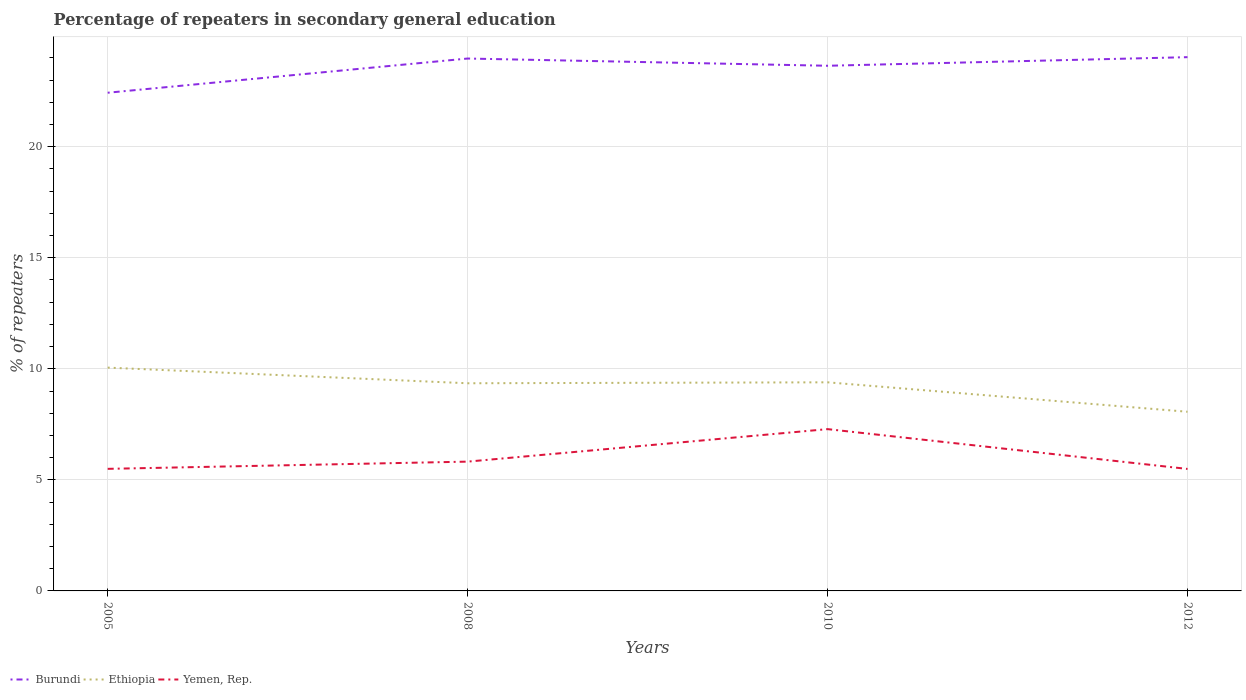How many different coloured lines are there?
Provide a succinct answer. 3. Does the line corresponding to Ethiopia intersect with the line corresponding to Yemen, Rep.?
Offer a very short reply. No. Across all years, what is the maximum percentage of repeaters in secondary general education in Ethiopia?
Offer a very short reply. 8.07. What is the total percentage of repeaters in secondary general education in Yemen, Rep. in the graph?
Ensure brevity in your answer.  0. What is the difference between the highest and the second highest percentage of repeaters in secondary general education in Ethiopia?
Make the answer very short. 1.99. Is the percentage of repeaters in secondary general education in Burundi strictly greater than the percentage of repeaters in secondary general education in Yemen, Rep. over the years?
Offer a very short reply. No. How many years are there in the graph?
Offer a terse response. 4. What is the difference between two consecutive major ticks on the Y-axis?
Ensure brevity in your answer.  5. Are the values on the major ticks of Y-axis written in scientific E-notation?
Give a very brief answer. No. Does the graph contain any zero values?
Your answer should be compact. No. Where does the legend appear in the graph?
Your answer should be very brief. Bottom left. How are the legend labels stacked?
Provide a short and direct response. Horizontal. What is the title of the graph?
Your response must be concise. Percentage of repeaters in secondary general education. Does "Djibouti" appear as one of the legend labels in the graph?
Your response must be concise. No. What is the label or title of the Y-axis?
Make the answer very short. % of repeaters. What is the % of repeaters of Burundi in 2005?
Make the answer very short. 22.43. What is the % of repeaters of Ethiopia in 2005?
Provide a succinct answer. 10.05. What is the % of repeaters in Yemen, Rep. in 2005?
Offer a terse response. 5.5. What is the % of repeaters in Burundi in 2008?
Your answer should be very brief. 23.97. What is the % of repeaters of Ethiopia in 2008?
Offer a terse response. 9.35. What is the % of repeaters of Yemen, Rep. in 2008?
Provide a short and direct response. 5.82. What is the % of repeaters of Burundi in 2010?
Provide a succinct answer. 23.64. What is the % of repeaters of Ethiopia in 2010?
Provide a short and direct response. 9.39. What is the % of repeaters of Yemen, Rep. in 2010?
Keep it short and to the point. 7.28. What is the % of repeaters of Burundi in 2012?
Your answer should be very brief. 24.03. What is the % of repeaters of Ethiopia in 2012?
Your answer should be compact. 8.07. What is the % of repeaters in Yemen, Rep. in 2012?
Your answer should be compact. 5.49. Across all years, what is the maximum % of repeaters of Burundi?
Keep it short and to the point. 24.03. Across all years, what is the maximum % of repeaters of Ethiopia?
Your response must be concise. 10.05. Across all years, what is the maximum % of repeaters of Yemen, Rep.?
Your answer should be very brief. 7.28. Across all years, what is the minimum % of repeaters of Burundi?
Ensure brevity in your answer.  22.43. Across all years, what is the minimum % of repeaters in Ethiopia?
Provide a short and direct response. 8.07. Across all years, what is the minimum % of repeaters in Yemen, Rep.?
Provide a short and direct response. 5.49. What is the total % of repeaters in Burundi in the graph?
Offer a terse response. 94.08. What is the total % of repeaters in Ethiopia in the graph?
Ensure brevity in your answer.  36.86. What is the total % of repeaters in Yemen, Rep. in the graph?
Make the answer very short. 24.09. What is the difference between the % of repeaters of Burundi in 2005 and that in 2008?
Make the answer very short. -1.54. What is the difference between the % of repeaters in Ethiopia in 2005 and that in 2008?
Keep it short and to the point. 0.7. What is the difference between the % of repeaters in Yemen, Rep. in 2005 and that in 2008?
Your response must be concise. -0.33. What is the difference between the % of repeaters in Burundi in 2005 and that in 2010?
Your answer should be compact. -1.21. What is the difference between the % of repeaters of Ethiopia in 2005 and that in 2010?
Give a very brief answer. 0.66. What is the difference between the % of repeaters in Yemen, Rep. in 2005 and that in 2010?
Your answer should be very brief. -1.79. What is the difference between the % of repeaters in Burundi in 2005 and that in 2012?
Offer a terse response. -1.6. What is the difference between the % of repeaters of Ethiopia in 2005 and that in 2012?
Offer a terse response. 1.99. What is the difference between the % of repeaters of Yemen, Rep. in 2005 and that in 2012?
Your answer should be compact. 0. What is the difference between the % of repeaters in Burundi in 2008 and that in 2010?
Provide a short and direct response. 0.33. What is the difference between the % of repeaters of Ethiopia in 2008 and that in 2010?
Make the answer very short. -0.04. What is the difference between the % of repeaters in Yemen, Rep. in 2008 and that in 2010?
Your answer should be very brief. -1.46. What is the difference between the % of repeaters of Burundi in 2008 and that in 2012?
Ensure brevity in your answer.  -0.06. What is the difference between the % of repeaters in Ethiopia in 2008 and that in 2012?
Make the answer very short. 1.28. What is the difference between the % of repeaters in Yemen, Rep. in 2008 and that in 2012?
Make the answer very short. 0.33. What is the difference between the % of repeaters in Burundi in 2010 and that in 2012?
Keep it short and to the point. -0.39. What is the difference between the % of repeaters of Ethiopia in 2010 and that in 2012?
Your answer should be very brief. 1.33. What is the difference between the % of repeaters in Yemen, Rep. in 2010 and that in 2012?
Your answer should be very brief. 1.79. What is the difference between the % of repeaters of Burundi in 2005 and the % of repeaters of Ethiopia in 2008?
Your answer should be very brief. 13.08. What is the difference between the % of repeaters in Burundi in 2005 and the % of repeaters in Yemen, Rep. in 2008?
Give a very brief answer. 16.61. What is the difference between the % of repeaters in Ethiopia in 2005 and the % of repeaters in Yemen, Rep. in 2008?
Your answer should be compact. 4.23. What is the difference between the % of repeaters of Burundi in 2005 and the % of repeaters of Ethiopia in 2010?
Provide a short and direct response. 13.04. What is the difference between the % of repeaters of Burundi in 2005 and the % of repeaters of Yemen, Rep. in 2010?
Keep it short and to the point. 15.15. What is the difference between the % of repeaters of Ethiopia in 2005 and the % of repeaters of Yemen, Rep. in 2010?
Your response must be concise. 2.77. What is the difference between the % of repeaters in Burundi in 2005 and the % of repeaters in Ethiopia in 2012?
Ensure brevity in your answer.  14.36. What is the difference between the % of repeaters in Burundi in 2005 and the % of repeaters in Yemen, Rep. in 2012?
Ensure brevity in your answer.  16.94. What is the difference between the % of repeaters of Ethiopia in 2005 and the % of repeaters of Yemen, Rep. in 2012?
Provide a succinct answer. 4.56. What is the difference between the % of repeaters of Burundi in 2008 and the % of repeaters of Ethiopia in 2010?
Make the answer very short. 14.58. What is the difference between the % of repeaters in Burundi in 2008 and the % of repeaters in Yemen, Rep. in 2010?
Offer a very short reply. 16.69. What is the difference between the % of repeaters in Ethiopia in 2008 and the % of repeaters in Yemen, Rep. in 2010?
Keep it short and to the point. 2.06. What is the difference between the % of repeaters of Burundi in 2008 and the % of repeaters of Ethiopia in 2012?
Provide a short and direct response. 15.9. What is the difference between the % of repeaters of Burundi in 2008 and the % of repeaters of Yemen, Rep. in 2012?
Offer a terse response. 18.48. What is the difference between the % of repeaters in Ethiopia in 2008 and the % of repeaters in Yemen, Rep. in 2012?
Your response must be concise. 3.86. What is the difference between the % of repeaters in Burundi in 2010 and the % of repeaters in Ethiopia in 2012?
Make the answer very short. 15.58. What is the difference between the % of repeaters in Burundi in 2010 and the % of repeaters in Yemen, Rep. in 2012?
Your answer should be compact. 18.15. What is the difference between the % of repeaters of Ethiopia in 2010 and the % of repeaters of Yemen, Rep. in 2012?
Ensure brevity in your answer.  3.9. What is the average % of repeaters in Burundi per year?
Your answer should be compact. 23.52. What is the average % of repeaters of Ethiopia per year?
Make the answer very short. 9.22. What is the average % of repeaters in Yemen, Rep. per year?
Offer a terse response. 6.02. In the year 2005, what is the difference between the % of repeaters in Burundi and % of repeaters in Ethiopia?
Provide a short and direct response. 12.38. In the year 2005, what is the difference between the % of repeaters of Burundi and % of repeaters of Yemen, Rep.?
Give a very brief answer. 16.93. In the year 2005, what is the difference between the % of repeaters of Ethiopia and % of repeaters of Yemen, Rep.?
Make the answer very short. 4.56. In the year 2008, what is the difference between the % of repeaters in Burundi and % of repeaters in Ethiopia?
Offer a terse response. 14.62. In the year 2008, what is the difference between the % of repeaters of Burundi and % of repeaters of Yemen, Rep.?
Your answer should be compact. 18.15. In the year 2008, what is the difference between the % of repeaters of Ethiopia and % of repeaters of Yemen, Rep.?
Offer a terse response. 3.53. In the year 2010, what is the difference between the % of repeaters of Burundi and % of repeaters of Ethiopia?
Make the answer very short. 14.25. In the year 2010, what is the difference between the % of repeaters in Burundi and % of repeaters in Yemen, Rep.?
Your answer should be very brief. 16.36. In the year 2010, what is the difference between the % of repeaters in Ethiopia and % of repeaters in Yemen, Rep.?
Your answer should be compact. 2.11. In the year 2012, what is the difference between the % of repeaters of Burundi and % of repeaters of Ethiopia?
Your answer should be very brief. 15.97. In the year 2012, what is the difference between the % of repeaters in Burundi and % of repeaters in Yemen, Rep.?
Give a very brief answer. 18.54. In the year 2012, what is the difference between the % of repeaters of Ethiopia and % of repeaters of Yemen, Rep.?
Provide a short and direct response. 2.57. What is the ratio of the % of repeaters of Burundi in 2005 to that in 2008?
Ensure brevity in your answer.  0.94. What is the ratio of the % of repeaters of Ethiopia in 2005 to that in 2008?
Offer a very short reply. 1.08. What is the ratio of the % of repeaters of Yemen, Rep. in 2005 to that in 2008?
Provide a short and direct response. 0.94. What is the ratio of the % of repeaters in Burundi in 2005 to that in 2010?
Your answer should be compact. 0.95. What is the ratio of the % of repeaters in Ethiopia in 2005 to that in 2010?
Keep it short and to the point. 1.07. What is the ratio of the % of repeaters in Yemen, Rep. in 2005 to that in 2010?
Provide a short and direct response. 0.75. What is the ratio of the % of repeaters in Burundi in 2005 to that in 2012?
Offer a very short reply. 0.93. What is the ratio of the % of repeaters in Ethiopia in 2005 to that in 2012?
Provide a succinct answer. 1.25. What is the ratio of the % of repeaters of Yemen, Rep. in 2005 to that in 2012?
Provide a short and direct response. 1. What is the ratio of the % of repeaters of Burundi in 2008 to that in 2010?
Give a very brief answer. 1.01. What is the ratio of the % of repeaters of Yemen, Rep. in 2008 to that in 2010?
Provide a succinct answer. 0.8. What is the ratio of the % of repeaters in Burundi in 2008 to that in 2012?
Give a very brief answer. 1. What is the ratio of the % of repeaters of Ethiopia in 2008 to that in 2012?
Ensure brevity in your answer.  1.16. What is the ratio of the % of repeaters in Yemen, Rep. in 2008 to that in 2012?
Make the answer very short. 1.06. What is the ratio of the % of repeaters of Burundi in 2010 to that in 2012?
Make the answer very short. 0.98. What is the ratio of the % of repeaters in Ethiopia in 2010 to that in 2012?
Make the answer very short. 1.16. What is the ratio of the % of repeaters in Yemen, Rep. in 2010 to that in 2012?
Your answer should be compact. 1.33. What is the difference between the highest and the second highest % of repeaters of Burundi?
Your response must be concise. 0.06. What is the difference between the highest and the second highest % of repeaters in Ethiopia?
Your answer should be compact. 0.66. What is the difference between the highest and the second highest % of repeaters of Yemen, Rep.?
Offer a terse response. 1.46. What is the difference between the highest and the lowest % of repeaters of Burundi?
Provide a succinct answer. 1.6. What is the difference between the highest and the lowest % of repeaters in Ethiopia?
Your response must be concise. 1.99. What is the difference between the highest and the lowest % of repeaters of Yemen, Rep.?
Your response must be concise. 1.79. 